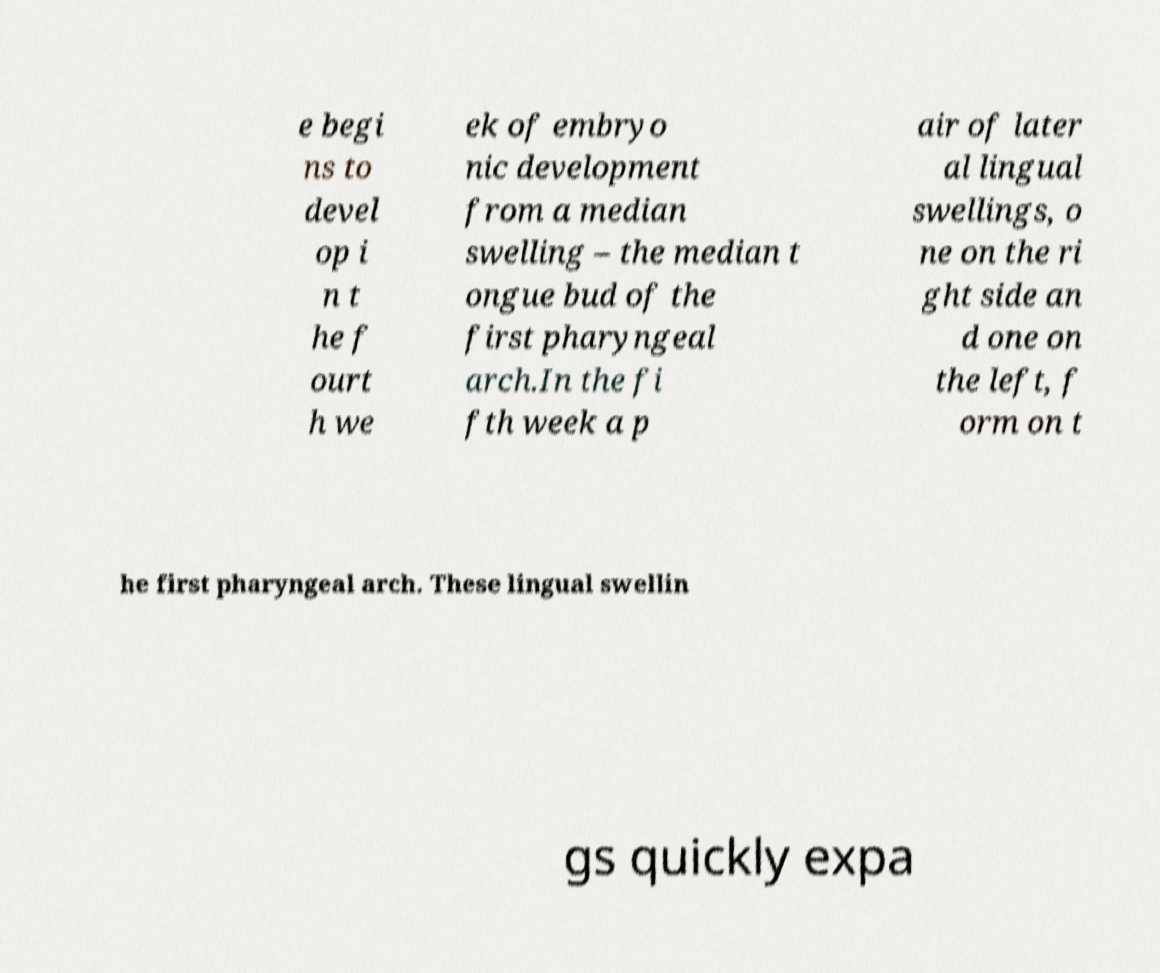Please read and relay the text visible in this image. What does it say? e begi ns to devel op i n t he f ourt h we ek of embryo nic development from a median swelling – the median t ongue bud of the first pharyngeal arch.In the fi fth week a p air of later al lingual swellings, o ne on the ri ght side an d one on the left, f orm on t he first pharyngeal arch. These lingual swellin gs quickly expa 